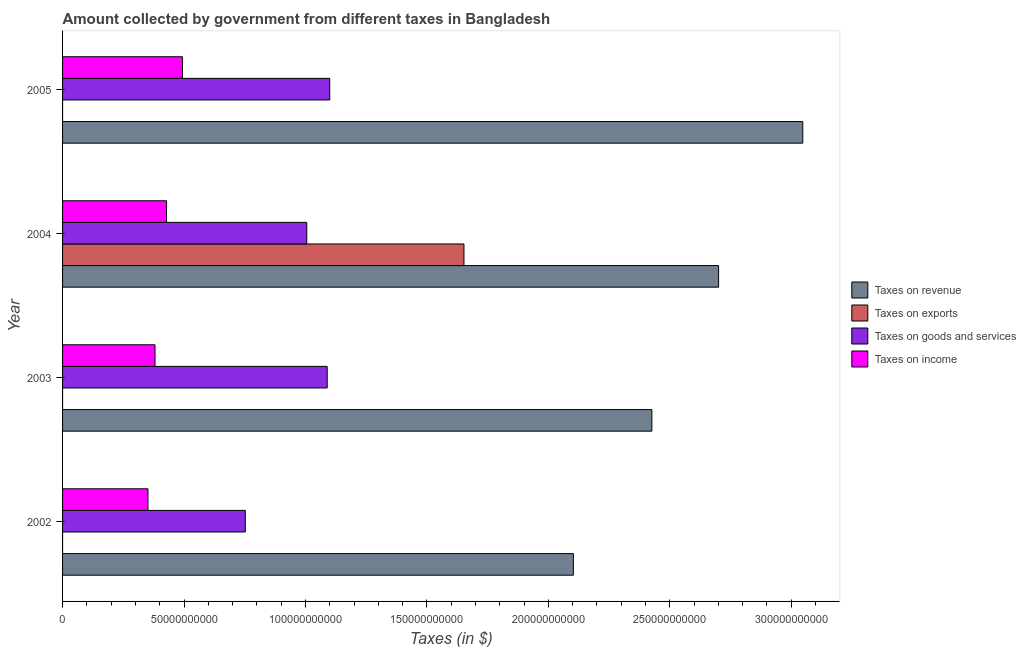How many different coloured bars are there?
Ensure brevity in your answer.  4. How many groups of bars are there?
Offer a terse response. 4. Are the number of bars per tick equal to the number of legend labels?
Your answer should be compact. Yes. Are the number of bars on each tick of the Y-axis equal?
Provide a short and direct response. Yes. How many bars are there on the 3rd tick from the top?
Keep it short and to the point. 4. How many bars are there on the 4th tick from the bottom?
Offer a terse response. 4. What is the label of the 2nd group of bars from the top?
Your answer should be compact. 2004. What is the amount collected as tax on goods in 2004?
Keep it short and to the point. 1.01e+11. Across all years, what is the maximum amount collected as tax on income?
Your answer should be compact. 4.94e+1. Across all years, what is the minimum amount collected as tax on goods?
Your answer should be very brief. 7.52e+1. What is the total amount collected as tax on income in the graph?
Ensure brevity in your answer.  1.65e+11. What is the difference between the amount collected as tax on exports in 2003 and that in 2005?
Your answer should be very brief. 3.30e+05. What is the difference between the amount collected as tax on income in 2002 and the amount collected as tax on revenue in 2005?
Keep it short and to the point. -2.70e+11. What is the average amount collected as tax on revenue per year?
Your response must be concise. 2.57e+11. In the year 2003, what is the difference between the amount collected as tax on income and amount collected as tax on revenue?
Give a very brief answer. -2.05e+11. In how many years, is the amount collected as tax on exports greater than 250000000000 $?
Offer a terse response. 0. What is the ratio of the amount collected as tax on goods in 2002 to that in 2003?
Provide a succinct answer. 0.69. Is the amount collected as tax on income in 2002 less than that in 2003?
Offer a very short reply. Yes. What is the difference between the highest and the second highest amount collected as tax on goods?
Keep it short and to the point. 1.04e+09. What is the difference between the highest and the lowest amount collected as tax on revenue?
Provide a succinct answer. 9.44e+1. In how many years, is the amount collected as tax on income greater than the average amount collected as tax on income taken over all years?
Offer a terse response. 2. Is it the case that in every year, the sum of the amount collected as tax on revenue and amount collected as tax on exports is greater than the sum of amount collected as tax on goods and amount collected as tax on income?
Offer a terse response. Yes. What does the 4th bar from the top in 2005 represents?
Keep it short and to the point. Taxes on revenue. What does the 2nd bar from the bottom in 2003 represents?
Make the answer very short. Taxes on exports. Is it the case that in every year, the sum of the amount collected as tax on revenue and amount collected as tax on exports is greater than the amount collected as tax on goods?
Offer a very short reply. Yes. How many years are there in the graph?
Make the answer very short. 4. What is the difference between two consecutive major ticks on the X-axis?
Your answer should be compact. 5.00e+1. Are the values on the major ticks of X-axis written in scientific E-notation?
Ensure brevity in your answer.  No. Does the graph contain any zero values?
Your answer should be very brief. No. Does the graph contain grids?
Your answer should be compact. No. What is the title of the graph?
Offer a terse response. Amount collected by government from different taxes in Bangladesh. What is the label or title of the X-axis?
Ensure brevity in your answer.  Taxes (in $). What is the label or title of the Y-axis?
Your response must be concise. Year. What is the Taxes (in $) in Taxes on revenue in 2002?
Your answer should be very brief. 2.10e+11. What is the Taxes (in $) in Taxes on exports in 2002?
Your response must be concise. 10000. What is the Taxes (in $) in Taxes on goods and services in 2002?
Offer a very short reply. 7.52e+1. What is the Taxes (in $) in Taxes on income in 2002?
Your response must be concise. 3.52e+1. What is the Taxes (in $) of Taxes on revenue in 2003?
Keep it short and to the point. 2.43e+11. What is the Taxes (in $) of Taxes on exports in 2003?
Offer a very short reply. 3.38e+05. What is the Taxes (in $) of Taxes on goods and services in 2003?
Your answer should be very brief. 1.09e+11. What is the Taxes (in $) of Taxes on income in 2003?
Make the answer very short. 3.81e+1. What is the Taxes (in $) in Taxes on revenue in 2004?
Give a very brief answer. 2.70e+11. What is the Taxes (in $) in Taxes on exports in 2004?
Offer a very short reply. 1.65e+11. What is the Taxes (in $) of Taxes on goods and services in 2004?
Give a very brief answer. 1.01e+11. What is the Taxes (in $) in Taxes on income in 2004?
Offer a terse response. 4.28e+1. What is the Taxes (in $) in Taxes on revenue in 2005?
Provide a succinct answer. 3.05e+11. What is the Taxes (in $) in Taxes on exports in 2005?
Provide a succinct answer. 8000. What is the Taxes (in $) in Taxes on goods and services in 2005?
Your answer should be very brief. 1.10e+11. What is the Taxes (in $) of Taxes on income in 2005?
Give a very brief answer. 4.94e+1. Across all years, what is the maximum Taxes (in $) of Taxes on revenue?
Ensure brevity in your answer.  3.05e+11. Across all years, what is the maximum Taxes (in $) in Taxes on exports?
Your answer should be compact. 1.65e+11. Across all years, what is the maximum Taxes (in $) of Taxes on goods and services?
Make the answer very short. 1.10e+11. Across all years, what is the maximum Taxes (in $) of Taxes on income?
Provide a short and direct response. 4.94e+1. Across all years, what is the minimum Taxes (in $) in Taxes on revenue?
Keep it short and to the point. 2.10e+11. Across all years, what is the minimum Taxes (in $) in Taxes on exports?
Make the answer very short. 8000. Across all years, what is the minimum Taxes (in $) in Taxes on goods and services?
Your answer should be very brief. 7.52e+1. Across all years, what is the minimum Taxes (in $) in Taxes on income?
Make the answer very short. 3.52e+1. What is the total Taxes (in $) of Taxes on revenue in the graph?
Give a very brief answer. 1.03e+12. What is the total Taxes (in $) of Taxes on exports in the graph?
Offer a terse response. 1.65e+11. What is the total Taxes (in $) in Taxes on goods and services in the graph?
Give a very brief answer. 3.95e+11. What is the total Taxes (in $) in Taxes on income in the graph?
Offer a terse response. 1.65e+11. What is the difference between the Taxes (in $) in Taxes on revenue in 2002 and that in 2003?
Offer a terse response. -3.23e+1. What is the difference between the Taxes (in $) of Taxes on exports in 2002 and that in 2003?
Provide a short and direct response. -3.28e+05. What is the difference between the Taxes (in $) of Taxes on goods and services in 2002 and that in 2003?
Keep it short and to the point. -3.37e+1. What is the difference between the Taxes (in $) in Taxes on income in 2002 and that in 2003?
Provide a succinct answer. -2.91e+09. What is the difference between the Taxes (in $) in Taxes on revenue in 2002 and that in 2004?
Ensure brevity in your answer.  -5.98e+1. What is the difference between the Taxes (in $) of Taxes on exports in 2002 and that in 2004?
Keep it short and to the point. -1.65e+11. What is the difference between the Taxes (in $) in Taxes on goods and services in 2002 and that in 2004?
Your answer should be very brief. -2.53e+1. What is the difference between the Taxes (in $) in Taxes on income in 2002 and that in 2004?
Your answer should be very brief. -7.66e+09. What is the difference between the Taxes (in $) of Taxes on revenue in 2002 and that in 2005?
Your answer should be compact. -9.44e+1. What is the difference between the Taxes (in $) of Taxes on exports in 2002 and that in 2005?
Offer a terse response. 2000. What is the difference between the Taxes (in $) in Taxes on goods and services in 2002 and that in 2005?
Give a very brief answer. -3.48e+1. What is the difference between the Taxes (in $) in Taxes on income in 2002 and that in 2005?
Offer a terse response. -1.42e+1. What is the difference between the Taxes (in $) in Taxes on revenue in 2003 and that in 2004?
Give a very brief answer. -2.75e+1. What is the difference between the Taxes (in $) of Taxes on exports in 2003 and that in 2004?
Provide a succinct answer. -1.65e+11. What is the difference between the Taxes (in $) of Taxes on goods and services in 2003 and that in 2004?
Keep it short and to the point. 8.41e+09. What is the difference between the Taxes (in $) of Taxes on income in 2003 and that in 2004?
Give a very brief answer. -4.74e+09. What is the difference between the Taxes (in $) in Taxes on revenue in 2003 and that in 2005?
Give a very brief answer. -6.21e+1. What is the difference between the Taxes (in $) in Taxes on goods and services in 2003 and that in 2005?
Make the answer very short. -1.04e+09. What is the difference between the Taxes (in $) in Taxes on income in 2003 and that in 2005?
Offer a terse response. -1.13e+1. What is the difference between the Taxes (in $) of Taxes on revenue in 2004 and that in 2005?
Your answer should be very brief. -3.47e+1. What is the difference between the Taxes (in $) of Taxes on exports in 2004 and that in 2005?
Your response must be concise. 1.65e+11. What is the difference between the Taxes (in $) in Taxes on goods and services in 2004 and that in 2005?
Offer a very short reply. -9.45e+09. What is the difference between the Taxes (in $) in Taxes on income in 2004 and that in 2005?
Keep it short and to the point. -6.56e+09. What is the difference between the Taxes (in $) in Taxes on revenue in 2002 and the Taxes (in $) in Taxes on exports in 2003?
Give a very brief answer. 2.10e+11. What is the difference between the Taxes (in $) in Taxes on revenue in 2002 and the Taxes (in $) in Taxes on goods and services in 2003?
Your response must be concise. 1.01e+11. What is the difference between the Taxes (in $) in Taxes on revenue in 2002 and the Taxes (in $) in Taxes on income in 2003?
Offer a terse response. 1.72e+11. What is the difference between the Taxes (in $) of Taxes on exports in 2002 and the Taxes (in $) of Taxes on goods and services in 2003?
Your response must be concise. -1.09e+11. What is the difference between the Taxes (in $) of Taxes on exports in 2002 and the Taxes (in $) of Taxes on income in 2003?
Keep it short and to the point. -3.81e+1. What is the difference between the Taxes (in $) of Taxes on goods and services in 2002 and the Taxes (in $) of Taxes on income in 2003?
Give a very brief answer. 3.72e+1. What is the difference between the Taxes (in $) of Taxes on revenue in 2002 and the Taxes (in $) of Taxes on exports in 2004?
Your response must be concise. 4.50e+1. What is the difference between the Taxes (in $) of Taxes on revenue in 2002 and the Taxes (in $) of Taxes on goods and services in 2004?
Ensure brevity in your answer.  1.10e+11. What is the difference between the Taxes (in $) of Taxes on revenue in 2002 and the Taxes (in $) of Taxes on income in 2004?
Make the answer very short. 1.67e+11. What is the difference between the Taxes (in $) of Taxes on exports in 2002 and the Taxes (in $) of Taxes on goods and services in 2004?
Offer a terse response. -1.01e+11. What is the difference between the Taxes (in $) in Taxes on exports in 2002 and the Taxes (in $) in Taxes on income in 2004?
Ensure brevity in your answer.  -4.28e+1. What is the difference between the Taxes (in $) in Taxes on goods and services in 2002 and the Taxes (in $) in Taxes on income in 2004?
Offer a terse response. 3.24e+1. What is the difference between the Taxes (in $) in Taxes on revenue in 2002 and the Taxes (in $) in Taxes on exports in 2005?
Your response must be concise. 2.10e+11. What is the difference between the Taxes (in $) in Taxes on revenue in 2002 and the Taxes (in $) in Taxes on goods and services in 2005?
Make the answer very short. 1.00e+11. What is the difference between the Taxes (in $) of Taxes on revenue in 2002 and the Taxes (in $) of Taxes on income in 2005?
Your response must be concise. 1.61e+11. What is the difference between the Taxes (in $) in Taxes on exports in 2002 and the Taxes (in $) in Taxes on goods and services in 2005?
Give a very brief answer. -1.10e+11. What is the difference between the Taxes (in $) in Taxes on exports in 2002 and the Taxes (in $) in Taxes on income in 2005?
Your answer should be compact. -4.94e+1. What is the difference between the Taxes (in $) of Taxes on goods and services in 2002 and the Taxes (in $) of Taxes on income in 2005?
Provide a short and direct response. 2.59e+1. What is the difference between the Taxes (in $) in Taxes on revenue in 2003 and the Taxes (in $) in Taxes on exports in 2004?
Offer a very short reply. 7.74e+1. What is the difference between the Taxes (in $) of Taxes on revenue in 2003 and the Taxes (in $) of Taxes on goods and services in 2004?
Ensure brevity in your answer.  1.42e+11. What is the difference between the Taxes (in $) in Taxes on revenue in 2003 and the Taxes (in $) in Taxes on income in 2004?
Provide a succinct answer. 2.00e+11. What is the difference between the Taxes (in $) in Taxes on exports in 2003 and the Taxes (in $) in Taxes on goods and services in 2004?
Provide a short and direct response. -1.01e+11. What is the difference between the Taxes (in $) in Taxes on exports in 2003 and the Taxes (in $) in Taxes on income in 2004?
Your answer should be very brief. -4.28e+1. What is the difference between the Taxes (in $) in Taxes on goods and services in 2003 and the Taxes (in $) in Taxes on income in 2004?
Give a very brief answer. 6.61e+1. What is the difference between the Taxes (in $) of Taxes on revenue in 2003 and the Taxes (in $) of Taxes on exports in 2005?
Offer a very short reply. 2.43e+11. What is the difference between the Taxes (in $) in Taxes on revenue in 2003 and the Taxes (in $) in Taxes on goods and services in 2005?
Provide a short and direct response. 1.33e+11. What is the difference between the Taxes (in $) of Taxes on revenue in 2003 and the Taxes (in $) of Taxes on income in 2005?
Provide a succinct answer. 1.93e+11. What is the difference between the Taxes (in $) in Taxes on exports in 2003 and the Taxes (in $) in Taxes on goods and services in 2005?
Keep it short and to the point. -1.10e+11. What is the difference between the Taxes (in $) of Taxes on exports in 2003 and the Taxes (in $) of Taxes on income in 2005?
Give a very brief answer. -4.94e+1. What is the difference between the Taxes (in $) of Taxes on goods and services in 2003 and the Taxes (in $) of Taxes on income in 2005?
Make the answer very short. 5.96e+1. What is the difference between the Taxes (in $) of Taxes on revenue in 2004 and the Taxes (in $) of Taxes on exports in 2005?
Provide a short and direct response. 2.70e+11. What is the difference between the Taxes (in $) in Taxes on revenue in 2004 and the Taxes (in $) in Taxes on goods and services in 2005?
Make the answer very short. 1.60e+11. What is the difference between the Taxes (in $) of Taxes on revenue in 2004 and the Taxes (in $) of Taxes on income in 2005?
Your answer should be compact. 2.21e+11. What is the difference between the Taxes (in $) of Taxes on exports in 2004 and the Taxes (in $) of Taxes on goods and services in 2005?
Give a very brief answer. 5.53e+1. What is the difference between the Taxes (in $) in Taxes on exports in 2004 and the Taxes (in $) in Taxes on income in 2005?
Provide a succinct answer. 1.16e+11. What is the difference between the Taxes (in $) of Taxes on goods and services in 2004 and the Taxes (in $) of Taxes on income in 2005?
Keep it short and to the point. 5.12e+1. What is the average Taxes (in $) in Taxes on revenue per year?
Make the answer very short. 2.57e+11. What is the average Taxes (in $) in Taxes on exports per year?
Offer a terse response. 4.13e+1. What is the average Taxes (in $) of Taxes on goods and services per year?
Give a very brief answer. 9.87e+1. What is the average Taxes (in $) of Taxes on income per year?
Your answer should be very brief. 4.13e+1. In the year 2002, what is the difference between the Taxes (in $) of Taxes on revenue and Taxes (in $) of Taxes on exports?
Make the answer very short. 2.10e+11. In the year 2002, what is the difference between the Taxes (in $) in Taxes on revenue and Taxes (in $) in Taxes on goods and services?
Ensure brevity in your answer.  1.35e+11. In the year 2002, what is the difference between the Taxes (in $) in Taxes on revenue and Taxes (in $) in Taxes on income?
Offer a terse response. 1.75e+11. In the year 2002, what is the difference between the Taxes (in $) of Taxes on exports and Taxes (in $) of Taxes on goods and services?
Offer a terse response. -7.52e+1. In the year 2002, what is the difference between the Taxes (in $) in Taxes on exports and Taxes (in $) in Taxes on income?
Your answer should be compact. -3.52e+1. In the year 2002, what is the difference between the Taxes (in $) of Taxes on goods and services and Taxes (in $) of Taxes on income?
Provide a short and direct response. 4.01e+1. In the year 2003, what is the difference between the Taxes (in $) of Taxes on revenue and Taxes (in $) of Taxes on exports?
Offer a very short reply. 2.43e+11. In the year 2003, what is the difference between the Taxes (in $) of Taxes on revenue and Taxes (in $) of Taxes on goods and services?
Offer a very short reply. 1.34e+11. In the year 2003, what is the difference between the Taxes (in $) of Taxes on revenue and Taxes (in $) of Taxes on income?
Your response must be concise. 2.05e+11. In the year 2003, what is the difference between the Taxes (in $) of Taxes on exports and Taxes (in $) of Taxes on goods and services?
Keep it short and to the point. -1.09e+11. In the year 2003, what is the difference between the Taxes (in $) in Taxes on exports and Taxes (in $) in Taxes on income?
Provide a short and direct response. -3.81e+1. In the year 2003, what is the difference between the Taxes (in $) of Taxes on goods and services and Taxes (in $) of Taxes on income?
Your answer should be compact. 7.09e+1. In the year 2004, what is the difference between the Taxes (in $) in Taxes on revenue and Taxes (in $) in Taxes on exports?
Offer a terse response. 1.05e+11. In the year 2004, what is the difference between the Taxes (in $) in Taxes on revenue and Taxes (in $) in Taxes on goods and services?
Ensure brevity in your answer.  1.70e+11. In the year 2004, what is the difference between the Taxes (in $) in Taxes on revenue and Taxes (in $) in Taxes on income?
Offer a very short reply. 2.27e+11. In the year 2004, what is the difference between the Taxes (in $) in Taxes on exports and Taxes (in $) in Taxes on goods and services?
Your response must be concise. 6.47e+1. In the year 2004, what is the difference between the Taxes (in $) of Taxes on exports and Taxes (in $) of Taxes on income?
Offer a very short reply. 1.22e+11. In the year 2004, what is the difference between the Taxes (in $) of Taxes on goods and services and Taxes (in $) of Taxes on income?
Your answer should be very brief. 5.77e+1. In the year 2005, what is the difference between the Taxes (in $) of Taxes on revenue and Taxes (in $) of Taxes on exports?
Make the answer very short. 3.05e+11. In the year 2005, what is the difference between the Taxes (in $) in Taxes on revenue and Taxes (in $) in Taxes on goods and services?
Provide a short and direct response. 1.95e+11. In the year 2005, what is the difference between the Taxes (in $) of Taxes on revenue and Taxes (in $) of Taxes on income?
Keep it short and to the point. 2.55e+11. In the year 2005, what is the difference between the Taxes (in $) in Taxes on exports and Taxes (in $) in Taxes on goods and services?
Provide a succinct answer. -1.10e+11. In the year 2005, what is the difference between the Taxes (in $) in Taxes on exports and Taxes (in $) in Taxes on income?
Offer a terse response. -4.94e+1. In the year 2005, what is the difference between the Taxes (in $) in Taxes on goods and services and Taxes (in $) in Taxes on income?
Your answer should be compact. 6.06e+1. What is the ratio of the Taxes (in $) of Taxes on revenue in 2002 to that in 2003?
Provide a short and direct response. 0.87. What is the ratio of the Taxes (in $) in Taxes on exports in 2002 to that in 2003?
Give a very brief answer. 0.03. What is the ratio of the Taxes (in $) of Taxes on goods and services in 2002 to that in 2003?
Provide a succinct answer. 0.69. What is the ratio of the Taxes (in $) in Taxes on income in 2002 to that in 2003?
Provide a short and direct response. 0.92. What is the ratio of the Taxes (in $) in Taxes on revenue in 2002 to that in 2004?
Offer a very short reply. 0.78. What is the ratio of the Taxes (in $) of Taxes on exports in 2002 to that in 2004?
Keep it short and to the point. 0. What is the ratio of the Taxes (in $) in Taxes on goods and services in 2002 to that in 2004?
Ensure brevity in your answer.  0.75. What is the ratio of the Taxes (in $) of Taxes on income in 2002 to that in 2004?
Your answer should be compact. 0.82. What is the ratio of the Taxes (in $) of Taxes on revenue in 2002 to that in 2005?
Your answer should be compact. 0.69. What is the ratio of the Taxes (in $) in Taxes on goods and services in 2002 to that in 2005?
Keep it short and to the point. 0.68. What is the ratio of the Taxes (in $) of Taxes on income in 2002 to that in 2005?
Provide a succinct answer. 0.71. What is the ratio of the Taxes (in $) in Taxes on revenue in 2003 to that in 2004?
Make the answer very short. 0.9. What is the ratio of the Taxes (in $) of Taxes on exports in 2003 to that in 2004?
Offer a very short reply. 0. What is the ratio of the Taxes (in $) in Taxes on goods and services in 2003 to that in 2004?
Give a very brief answer. 1.08. What is the ratio of the Taxes (in $) of Taxes on income in 2003 to that in 2004?
Offer a terse response. 0.89. What is the ratio of the Taxes (in $) of Taxes on revenue in 2003 to that in 2005?
Your response must be concise. 0.8. What is the ratio of the Taxes (in $) in Taxes on exports in 2003 to that in 2005?
Ensure brevity in your answer.  42.25. What is the ratio of the Taxes (in $) in Taxes on income in 2003 to that in 2005?
Keep it short and to the point. 0.77. What is the ratio of the Taxes (in $) in Taxes on revenue in 2004 to that in 2005?
Provide a short and direct response. 0.89. What is the ratio of the Taxes (in $) of Taxes on exports in 2004 to that in 2005?
Your answer should be very brief. 2.07e+07. What is the ratio of the Taxes (in $) of Taxes on goods and services in 2004 to that in 2005?
Provide a short and direct response. 0.91. What is the ratio of the Taxes (in $) of Taxes on income in 2004 to that in 2005?
Offer a very short reply. 0.87. What is the difference between the highest and the second highest Taxes (in $) of Taxes on revenue?
Keep it short and to the point. 3.47e+1. What is the difference between the highest and the second highest Taxes (in $) of Taxes on exports?
Offer a terse response. 1.65e+11. What is the difference between the highest and the second highest Taxes (in $) of Taxes on goods and services?
Keep it short and to the point. 1.04e+09. What is the difference between the highest and the second highest Taxes (in $) in Taxes on income?
Keep it short and to the point. 6.56e+09. What is the difference between the highest and the lowest Taxes (in $) of Taxes on revenue?
Provide a succinct answer. 9.44e+1. What is the difference between the highest and the lowest Taxes (in $) in Taxes on exports?
Your answer should be very brief. 1.65e+11. What is the difference between the highest and the lowest Taxes (in $) of Taxes on goods and services?
Your answer should be very brief. 3.48e+1. What is the difference between the highest and the lowest Taxes (in $) in Taxes on income?
Ensure brevity in your answer.  1.42e+1. 